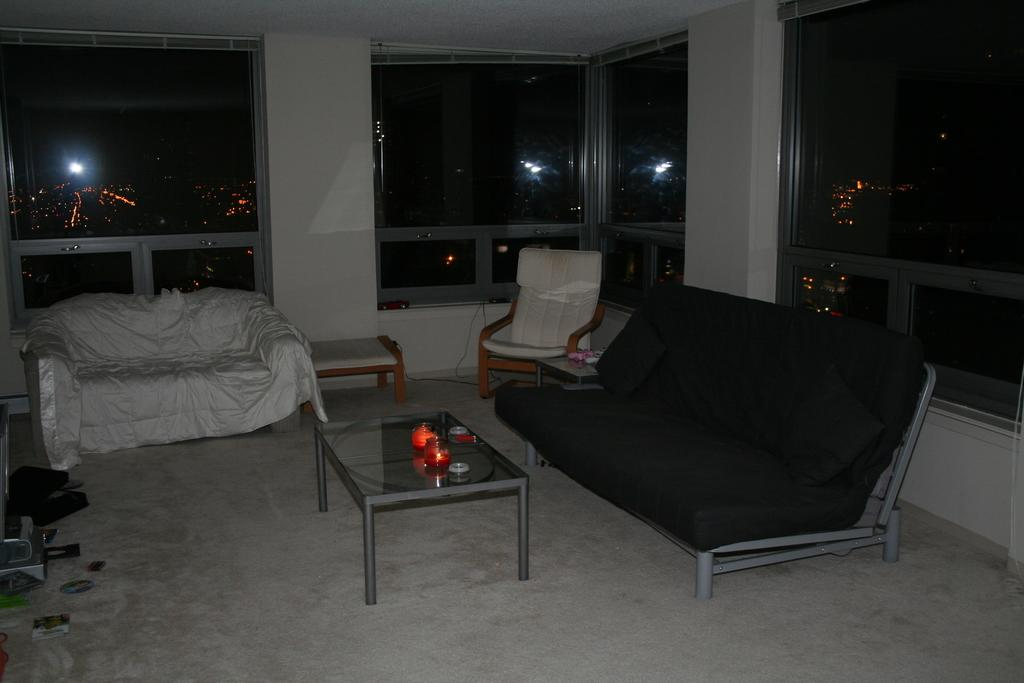What type of space is depicted in the image? There is a room in the image. What furniture is present in the room? There is a couch and a chair in the room. What other piece of furniture can be seen in the room? There is a teapoy in the room. What is on the floor in the room? There are objects on the floor in the room. How can natural light enter the room? There is a window in the room. What type of fish can be seen swimming in the room? There is no fish present in the room; it is an indoor space with furniture and objects. 